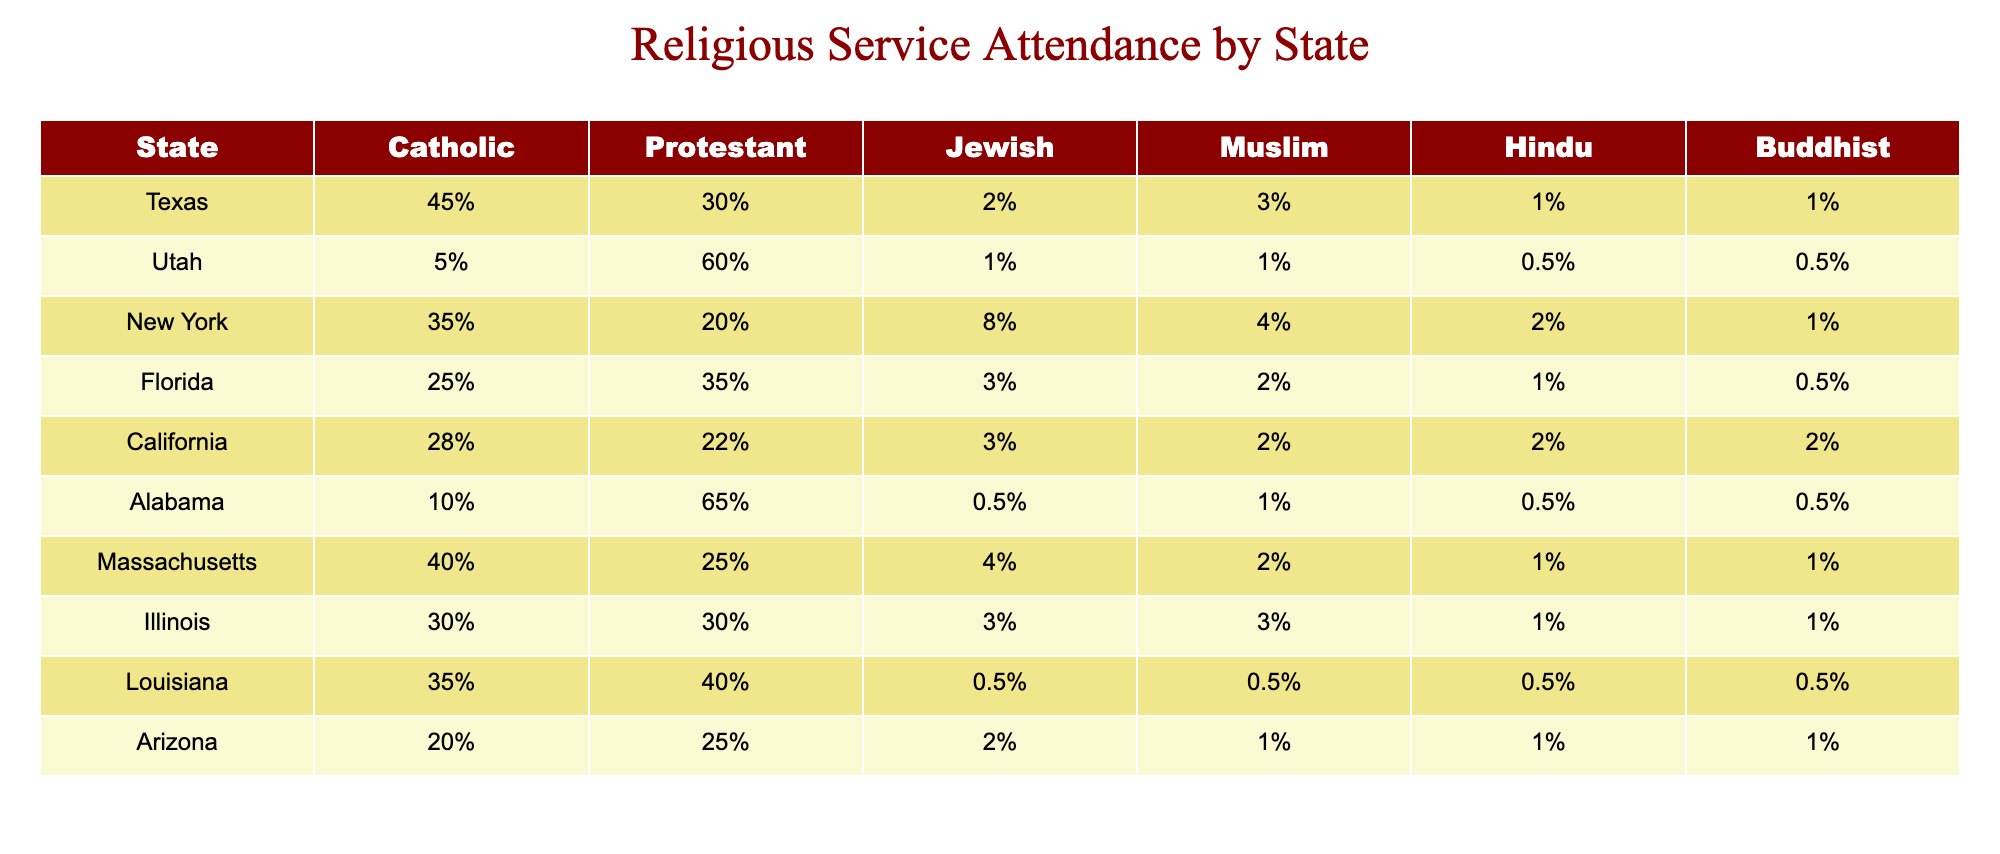What state has the highest percentage of Catholic attendance? By reviewing the table, Texas has the highest percentage of Catholic attendance at 45%, as no other state exceeds this value.
Answer: Texas Which state has the lowest percentage of Jewish attendance? The table shows that Alabama has the lowest percentage of Jewish attendance at 0.5%, as all other states have higher values.
Answer: Alabama What is the average percentage of Protestant attendance across all states? Summing the Protestant attendance percentages gives: 30% + 60% + 20% + 35% + 22% + 65% + 25% + 30% + 40% + 25% =  32%. Dividing the sum ( 30 + 60 + 20 + 35 + 22 + 65 + 25 + 30 + 40 + 25 =  35 ) by the number of states (10) results in an average of 35% / 10 = 32%.
Answer: 32% Is there any state with 0% attendance for Muslims? According to the table, no state lists a 0% attendance for Muslims; the lowest is 1%, found in Texas, Utah, and Arizona.
Answer: No Which state has the highest percentage of Hindu attendance and what is that percentage? Examining the table reveals that Utah has the highest percentage of Hindu attendance at 0.5%, as the other states report lower percentages, including 1% in Florida and Texas, but they are not higher than 0.5% for Utah.
Answer: Utah, 0.5% What is the difference in percentage of Protestant attendance between Alabama and New York? From the table, Alabama has a Protestant attendance of 65% and New York has 20%. The difference is calculated as follows: 65% - 20% = 45%.
Answer: 45% Which two states have the same percentage of Buddhist attendance? A look at the table shows that California and Texas both report a Buddhist attendance of 2%, making them the states with equal percentages.
Answer: California and Texas What is the total percentage of attendance for different religions in Florida? In Florida, the percentages for different religions are Catholic 25%, Protestant 35%, Jewish 3%, Muslim 2%, Hindu 1%, and Buddhist 0.5%. The total is calculated as 25 + 35 + 3 + 2 + 1 + 0.5 = 66.5%.
Answer: 66.5% 